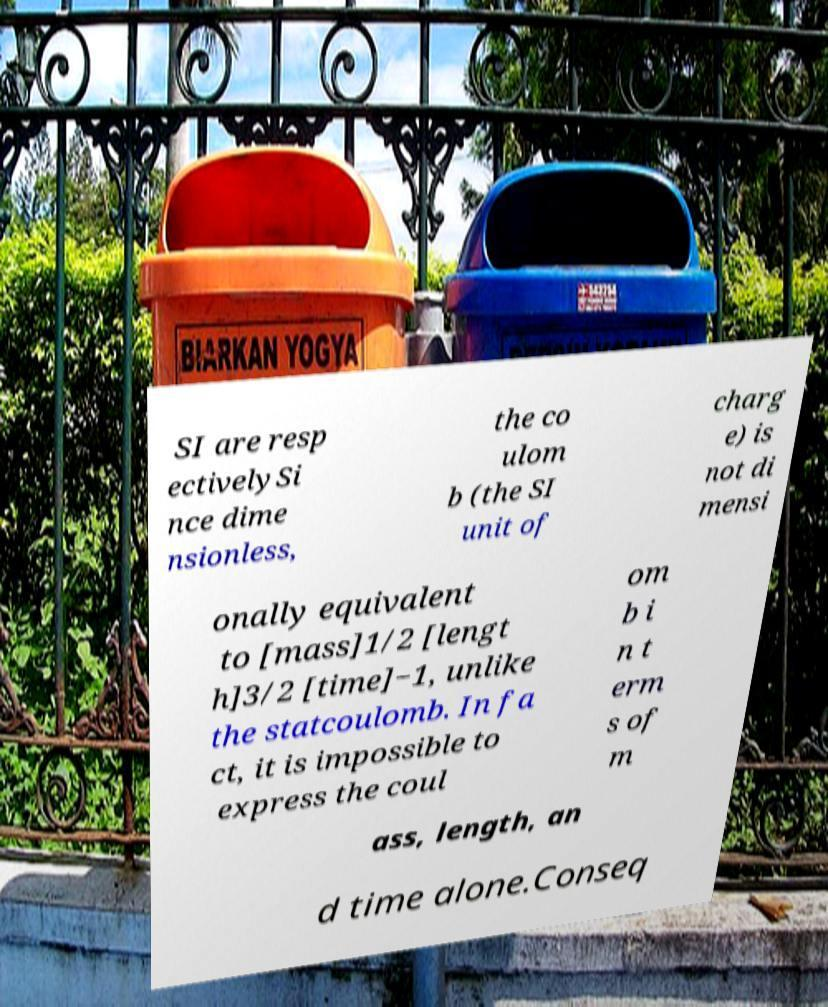Can you accurately transcribe the text from the provided image for me? SI are resp ectivelySi nce dime nsionless, the co ulom b (the SI unit of charg e) is not di mensi onally equivalent to [mass]1/2 [lengt h]3/2 [time]−1, unlike the statcoulomb. In fa ct, it is impossible to express the coul om b i n t erm s of m ass, length, an d time alone.Conseq 